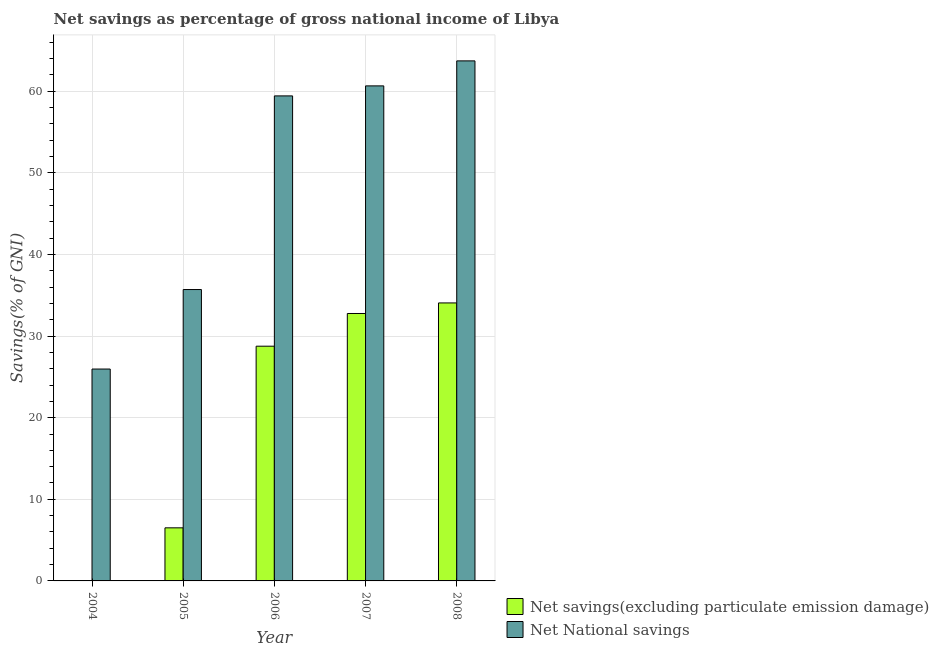How many different coloured bars are there?
Give a very brief answer. 2. Are the number of bars on each tick of the X-axis equal?
Make the answer very short. No. How many bars are there on the 2nd tick from the left?
Give a very brief answer. 2. How many bars are there on the 4th tick from the right?
Offer a terse response. 2. What is the label of the 1st group of bars from the left?
Give a very brief answer. 2004. In how many cases, is the number of bars for a given year not equal to the number of legend labels?
Make the answer very short. 1. What is the net national savings in 2006?
Provide a short and direct response. 59.43. Across all years, what is the maximum net savings(excluding particulate emission damage)?
Offer a terse response. 34.06. Across all years, what is the minimum net national savings?
Your response must be concise. 25.96. In which year was the net national savings maximum?
Provide a short and direct response. 2008. What is the total net national savings in the graph?
Your response must be concise. 245.47. What is the difference between the net national savings in 2005 and that in 2007?
Offer a terse response. -24.95. What is the difference between the net national savings in 2006 and the net savings(excluding particulate emission damage) in 2007?
Provide a succinct answer. -1.23. What is the average net savings(excluding particulate emission damage) per year?
Ensure brevity in your answer.  20.42. In how many years, is the net savings(excluding particulate emission damage) greater than 20 %?
Your answer should be very brief. 3. What is the ratio of the net savings(excluding particulate emission damage) in 2006 to that in 2007?
Your answer should be very brief. 0.88. Is the net savings(excluding particulate emission damage) in 2005 less than that in 2006?
Offer a very short reply. Yes. Is the difference between the net national savings in 2006 and 2008 greater than the difference between the net savings(excluding particulate emission damage) in 2006 and 2008?
Give a very brief answer. No. What is the difference between the highest and the second highest net savings(excluding particulate emission damage)?
Make the answer very short. 1.29. What is the difference between the highest and the lowest net savings(excluding particulate emission damage)?
Your answer should be compact. 34.06. Is the sum of the net national savings in 2005 and 2006 greater than the maximum net savings(excluding particulate emission damage) across all years?
Your answer should be very brief. Yes. Are all the bars in the graph horizontal?
Keep it short and to the point. No. How many years are there in the graph?
Offer a terse response. 5. Where does the legend appear in the graph?
Give a very brief answer. Bottom right. What is the title of the graph?
Make the answer very short. Net savings as percentage of gross national income of Libya. What is the label or title of the Y-axis?
Your answer should be very brief. Savings(% of GNI). What is the Savings(% of GNI) of Net National savings in 2004?
Offer a very short reply. 25.96. What is the Savings(% of GNI) in Net savings(excluding particulate emission damage) in 2005?
Provide a short and direct response. 6.51. What is the Savings(% of GNI) of Net National savings in 2005?
Your response must be concise. 35.7. What is the Savings(% of GNI) of Net savings(excluding particulate emission damage) in 2006?
Make the answer very short. 28.76. What is the Savings(% of GNI) in Net National savings in 2006?
Give a very brief answer. 59.43. What is the Savings(% of GNI) of Net savings(excluding particulate emission damage) in 2007?
Offer a very short reply. 32.77. What is the Savings(% of GNI) of Net National savings in 2007?
Offer a terse response. 60.66. What is the Savings(% of GNI) of Net savings(excluding particulate emission damage) in 2008?
Give a very brief answer. 34.06. What is the Savings(% of GNI) of Net National savings in 2008?
Give a very brief answer. 63.72. Across all years, what is the maximum Savings(% of GNI) of Net savings(excluding particulate emission damage)?
Your answer should be very brief. 34.06. Across all years, what is the maximum Savings(% of GNI) of Net National savings?
Offer a very short reply. 63.72. Across all years, what is the minimum Savings(% of GNI) of Net savings(excluding particulate emission damage)?
Give a very brief answer. 0. Across all years, what is the minimum Savings(% of GNI) in Net National savings?
Make the answer very short. 25.96. What is the total Savings(% of GNI) of Net savings(excluding particulate emission damage) in the graph?
Give a very brief answer. 102.1. What is the total Savings(% of GNI) in Net National savings in the graph?
Provide a short and direct response. 245.47. What is the difference between the Savings(% of GNI) of Net National savings in 2004 and that in 2005?
Make the answer very short. -9.74. What is the difference between the Savings(% of GNI) in Net National savings in 2004 and that in 2006?
Your answer should be very brief. -33.47. What is the difference between the Savings(% of GNI) in Net National savings in 2004 and that in 2007?
Ensure brevity in your answer.  -34.69. What is the difference between the Savings(% of GNI) of Net National savings in 2004 and that in 2008?
Your answer should be compact. -37.76. What is the difference between the Savings(% of GNI) in Net savings(excluding particulate emission damage) in 2005 and that in 2006?
Ensure brevity in your answer.  -22.25. What is the difference between the Savings(% of GNI) in Net National savings in 2005 and that in 2006?
Ensure brevity in your answer.  -23.73. What is the difference between the Savings(% of GNI) in Net savings(excluding particulate emission damage) in 2005 and that in 2007?
Offer a very short reply. -26.26. What is the difference between the Savings(% of GNI) in Net National savings in 2005 and that in 2007?
Provide a short and direct response. -24.95. What is the difference between the Savings(% of GNI) in Net savings(excluding particulate emission damage) in 2005 and that in 2008?
Offer a terse response. -27.56. What is the difference between the Savings(% of GNI) in Net National savings in 2005 and that in 2008?
Provide a short and direct response. -28.02. What is the difference between the Savings(% of GNI) of Net savings(excluding particulate emission damage) in 2006 and that in 2007?
Provide a succinct answer. -4.01. What is the difference between the Savings(% of GNI) in Net National savings in 2006 and that in 2007?
Offer a very short reply. -1.23. What is the difference between the Savings(% of GNI) of Net savings(excluding particulate emission damage) in 2006 and that in 2008?
Your answer should be very brief. -5.3. What is the difference between the Savings(% of GNI) of Net National savings in 2006 and that in 2008?
Keep it short and to the point. -4.29. What is the difference between the Savings(% of GNI) in Net savings(excluding particulate emission damage) in 2007 and that in 2008?
Your answer should be compact. -1.29. What is the difference between the Savings(% of GNI) of Net National savings in 2007 and that in 2008?
Provide a short and direct response. -3.06. What is the difference between the Savings(% of GNI) in Net savings(excluding particulate emission damage) in 2005 and the Savings(% of GNI) in Net National savings in 2006?
Provide a short and direct response. -52.92. What is the difference between the Savings(% of GNI) of Net savings(excluding particulate emission damage) in 2005 and the Savings(% of GNI) of Net National savings in 2007?
Keep it short and to the point. -54.15. What is the difference between the Savings(% of GNI) in Net savings(excluding particulate emission damage) in 2005 and the Savings(% of GNI) in Net National savings in 2008?
Your answer should be very brief. -57.22. What is the difference between the Savings(% of GNI) of Net savings(excluding particulate emission damage) in 2006 and the Savings(% of GNI) of Net National savings in 2007?
Ensure brevity in your answer.  -31.9. What is the difference between the Savings(% of GNI) of Net savings(excluding particulate emission damage) in 2006 and the Savings(% of GNI) of Net National savings in 2008?
Your answer should be very brief. -34.96. What is the difference between the Savings(% of GNI) in Net savings(excluding particulate emission damage) in 2007 and the Savings(% of GNI) in Net National savings in 2008?
Provide a short and direct response. -30.95. What is the average Savings(% of GNI) of Net savings(excluding particulate emission damage) per year?
Your answer should be compact. 20.42. What is the average Savings(% of GNI) of Net National savings per year?
Give a very brief answer. 49.09. In the year 2005, what is the difference between the Savings(% of GNI) of Net savings(excluding particulate emission damage) and Savings(% of GNI) of Net National savings?
Offer a very short reply. -29.2. In the year 2006, what is the difference between the Savings(% of GNI) of Net savings(excluding particulate emission damage) and Savings(% of GNI) of Net National savings?
Your answer should be very brief. -30.67. In the year 2007, what is the difference between the Savings(% of GNI) in Net savings(excluding particulate emission damage) and Savings(% of GNI) in Net National savings?
Offer a very short reply. -27.89. In the year 2008, what is the difference between the Savings(% of GNI) in Net savings(excluding particulate emission damage) and Savings(% of GNI) in Net National savings?
Keep it short and to the point. -29.66. What is the ratio of the Savings(% of GNI) in Net National savings in 2004 to that in 2005?
Your response must be concise. 0.73. What is the ratio of the Savings(% of GNI) of Net National savings in 2004 to that in 2006?
Offer a very short reply. 0.44. What is the ratio of the Savings(% of GNI) of Net National savings in 2004 to that in 2007?
Ensure brevity in your answer.  0.43. What is the ratio of the Savings(% of GNI) in Net National savings in 2004 to that in 2008?
Make the answer very short. 0.41. What is the ratio of the Savings(% of GNI) of Net savings(excluding particulate emission damage) in 2005 to that in 2006?
Offer a very short reply. 0.23. What is the ratio of the Savings(% of GNI) in Net National savings in 2005 to that in 2006?
Ensure brevity in your answer.  0.6. What is the ratio of the Savings(% of GNI) of Net savings(excluding particulate emission damage) in 2005 to that in 2007?
Make the answer very short. 0.2. What is the ratio of the Savings(% of GNI) in Net National savings in 2005 to that in 2007?
Your answer should be compact. 0.59. What is the ratio of the Savings(% of GNI) of Net savings(excluding particulate emission damage) in 2005 to that in 2008?
Your answer should be compact. 0.19. What is the ratio of the Savings(% of GNI) of Net National savings in 2005 to that in 2008?
Offer a terse response. 0.56. What is the ratio of the Savings(% of GNI) in Net savings(excluding particulate emission damage) in 2006 to that in 2007?
Provide a short and direct response. 0.88. What is the ratio of the Savings(% of GNI) of Net National savings in 2006 to that in 2007?
Make the answer very short. 0.98. What is the ratio of the Savings(% of GNI) in Net savings(excluding particulate emission damage) in 2006 to that in 2008?
Your answer should be very brief. 0.84. What is the ratio of the Savings(% of GNI) of Net National savings in 2006 to that in 2008?
Offer a very short reply. 0.93. What is the ratio of the Savings(% of GNI) of Net National savings in 2007 to that in 2008?
Give a very brief answer. 0.95. What is the difference between the highest and the second highest Savings(% of GNI) in Net savings(excluding particulate emission damage)?
Keep it short and to the point. 1.29. What is the difference between the highest and the second highest Savings(% of GNI) in Net National savings?
Your answer should be very brief. 3.06. What is the difference between the highest and the lowest Savings(% of GNI) of Net savings(excluding particulate emission damage)?
Provide a short and direct response. 34.06. What is the difference between the highest and the lowest Savings(% of GNI) in Net National savings?
Provide a succinct answer. 37.76. 